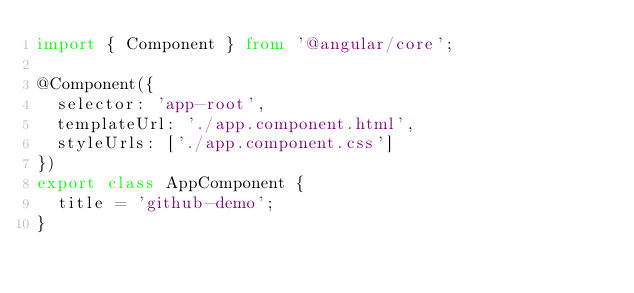Convert code to text. <code><loc_0><loc_0><loc_500><loc_500><_TypeScript_>import { Component } from '@angular/core';

@Component({
  selector: 'app-root',
  templateUrl: './app.component.html',
  styleUrls: ['./app.component.css']
})
export class AppComponent {
  title = 'github-demo';
}
</code> 